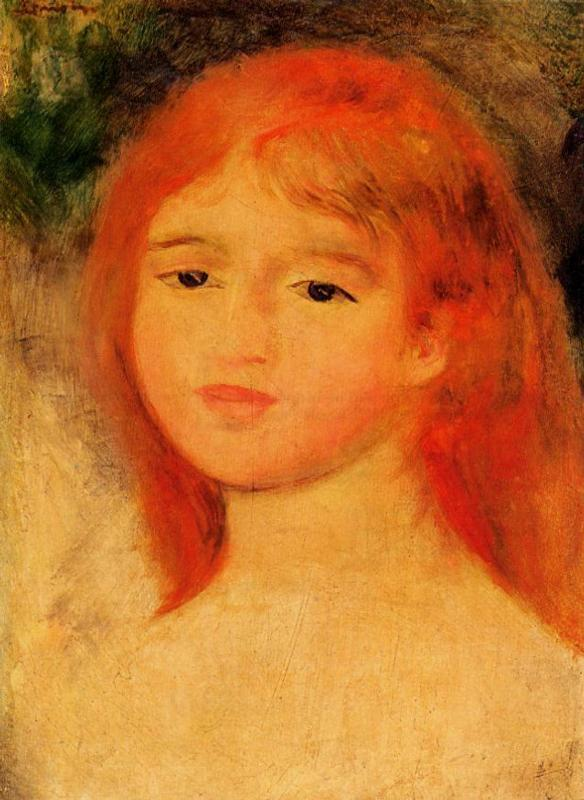What do you see happening in this image?
 The image is a captivating impressionist portrait of a young girl with vibrant red hair. The girl is depicted in a three-quarter view, her head gently tilted to the side, adding a sense of depth and perspective to the composition. Her hair, a striking shade of orange-red, stands out against the softer hues of the background. 

The background itself is a harmonious blend of green and yellow, with a subtle touch of blue in the top left corner, creating a serene atmosphere. The girl's complexion is pale, accentuated by the rosy blush on her cheeks, which adds a touch of warmth to her expression.

The painting is executed in the impressionist style, characterized by its loose brushstrokes and emphasis on color and light rather than detail. This style is evident in the way the colors are applied in broad, sweeping strokes, creating a sense of movement and life. The focus on color and light, rather than precise detail, is a hallmark of the impressionist genre, and it is beautifully demonstrated in this portrait. The overall effect is a vivid and lively representation of a young girl, captured in a moment of quiet contemplation. 